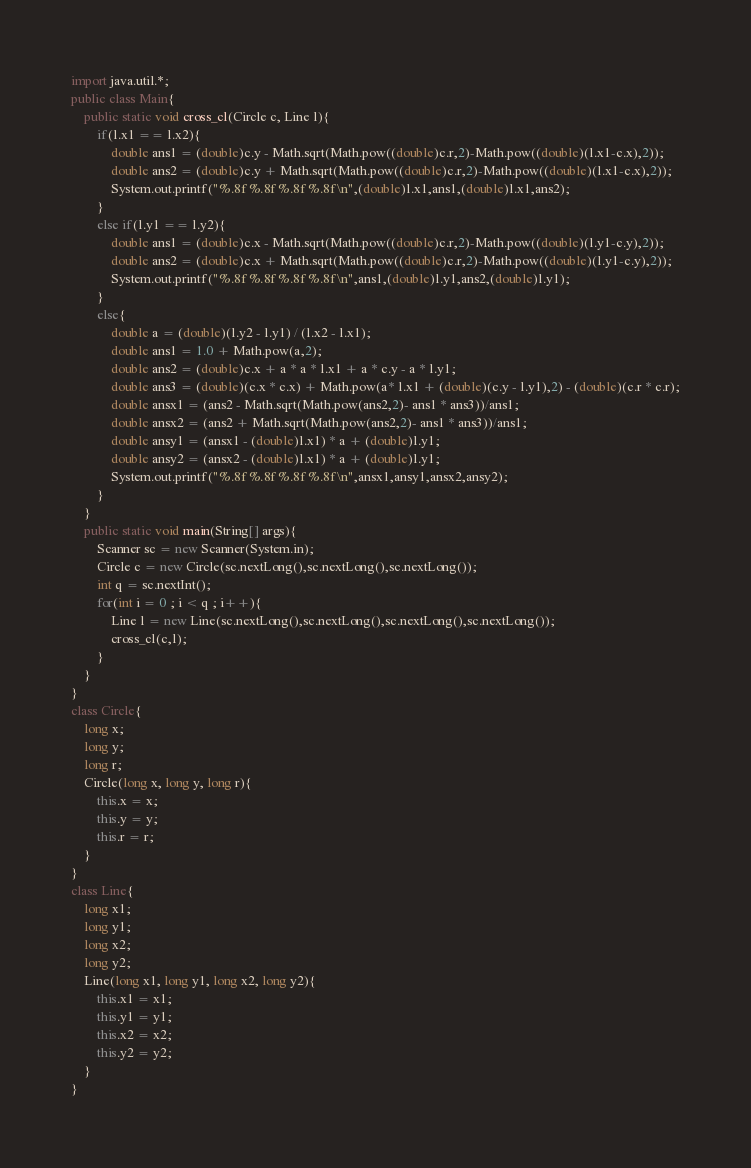Convert code to text. <code><loc_0><loc_0><loc_500><loc_500><_Java_>import java.util.*;
public class Main{
	public static void cross_cl(Circle c, Line l){
		if(l.x1 == l.x2){
			double ans1 = (double)c.y - Math.sqrt(Math.pow((double)c.r,2)-Math.pow((double)(l.x1-c.x),2));
			double ans2 = (double)c.y + Math.sqrt(Math.pow((double)c.r,2)-Math.pow((double)(l.x1-c.x),2));
			System.out.printf("%.8f %.8f %.8f %.8f\n",(double)l.x1,ans1,(double)l.x1,ans2);
		}
		else if(l.y1 == l.y2){
			double ans1 = (double)c.x - Math.sqrt(Math.pow((double)c.r,2)-Math.pow((double)(l.y1-c.y),2));
			double ans2 = (double)c.x + Math.sqrt(Math.pow((double)c.r,2)-Math.pow((double)(l.y1-c.y),2));
			System.out.printf("%.8f %.8f %.8f %.8f\n",ans1,(double)l.y1,ans2,(double)l.y1);
		}
		else{
			double a = (double)(l.y2 - l.y1) / (l.x2 - l.x1);
			double ans1 = 1.0 + Math.pow(a,2);
			double ans2 = (double)c.x + a * a * l.x1 + a * c.y - a * l.y1;
			double ans3 = (double)(c.x * c.x) + Math.pow(a* l.x1 + (double)(c.y - l.y1),2) - (double)(c.r * c.r);
			double ansx1 = (ans2 - Math.sqrt(Math.pow(ans2,2)- ans1 * ans3))/ans1;
			double ansx2 = (ans2 + Math.sqrt(Math.pow(ans2,2)- ans1 * ans3))/ans1;
			double ansy1 = (ansx1 - (double)l.x1) * a + (double)l.y1;
			double ansy2 = (ansx2 - (double)l.x1) * a + (double)l.y1;
			System.out.printf("%.8f %.8f %.8f %.8f\n",ansx1,ansy1,ansx2,ansy2);
		}
	}
	public static void main(String[] args){
		Scanner sc = new Scanner(System.in);
		Circle c = new Circle(sc.nextLong(),sc.nextLong(),sc.nextLong());
		int q = sc.nextInt();
		for(int i = 0 ; i < q ; i++){
			Line l = new Line(sc.nextLong(),sc.nextLong(),sc.nextLong(),sc.nextLong());
			cross_cl(c,l);
		}
	}
}
class Circle{
	long x;
	long y;
	long r;
	Circle(long x, long y, long r){
		this.x = x;
		this.y = y;
		this.r = r;
	}
}
class Line{
	long x1;
	long y1;
	long x2;
	long y2;
	Line(long x1, long y1, long x2, long y2){
		this.x1 = x1;
		this.y1 = y1;
		this.x2 = x2;
		this.y2 = y2;
	}
}
</code> 